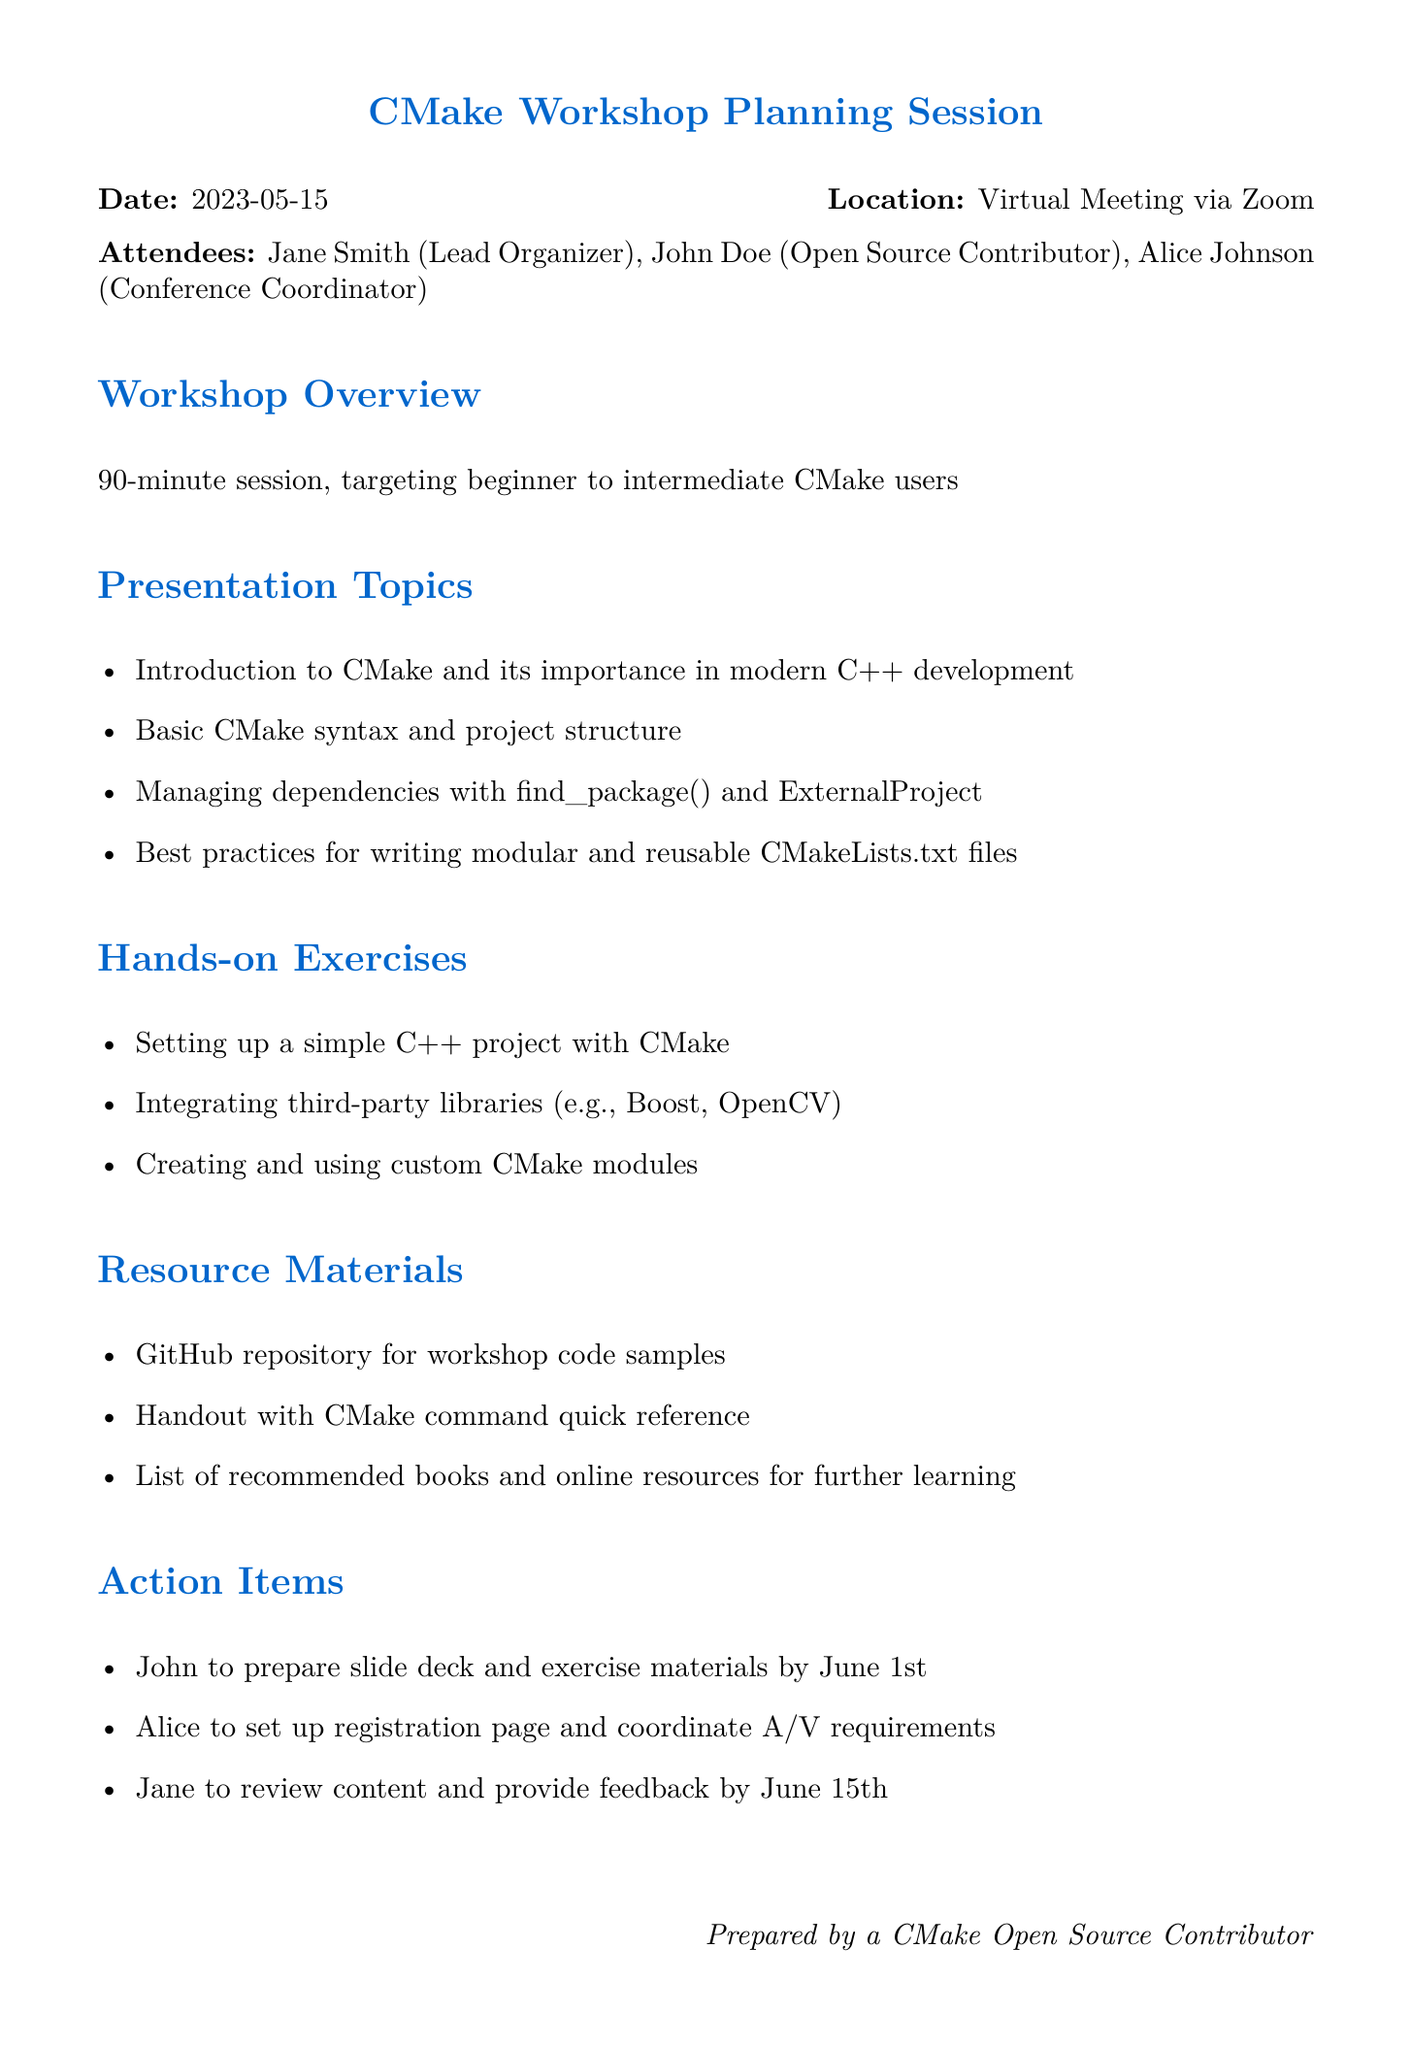What is the title of the meeting? The title of the meeting is specified in the document, which is where the details about the meeting are provided.
Answer: CMake Workshop Planning Session Who is the lead organizer? The document lists the attendees and their roles, making it clear who is responsible for leading the workshop.
Answer: Jane Smith When is the deadline for preparing slide deck and exercise materials? The document mentions action items with specific deadlines for various contributors, including John.
Answer: June 1st What is one of the hands-on exercises planned for the workshop? The document outlines several hands-on exercises that participants will engage in during the workshop.
Answer: Setting up a simple C++ project with CMake How long is the workshop session? The overview section provides the duration of the workshop session stated in the meeting details.
Answer: 90 minutes What type of users is the workshop targeting? The document specifies the target audience for the workshop in the overview section.
Answer: beginner to intermediate CMake users What is one of the resource materials to be provided? The resource materials section of the document lists different materials that will be made available for the participants.
Answer: GitHub repository for workshop code samples Who is responsible for setting up the registration page? The action items include responsibilities assigned to attendees, detailing who will manage the registration.
Answer: Alice 